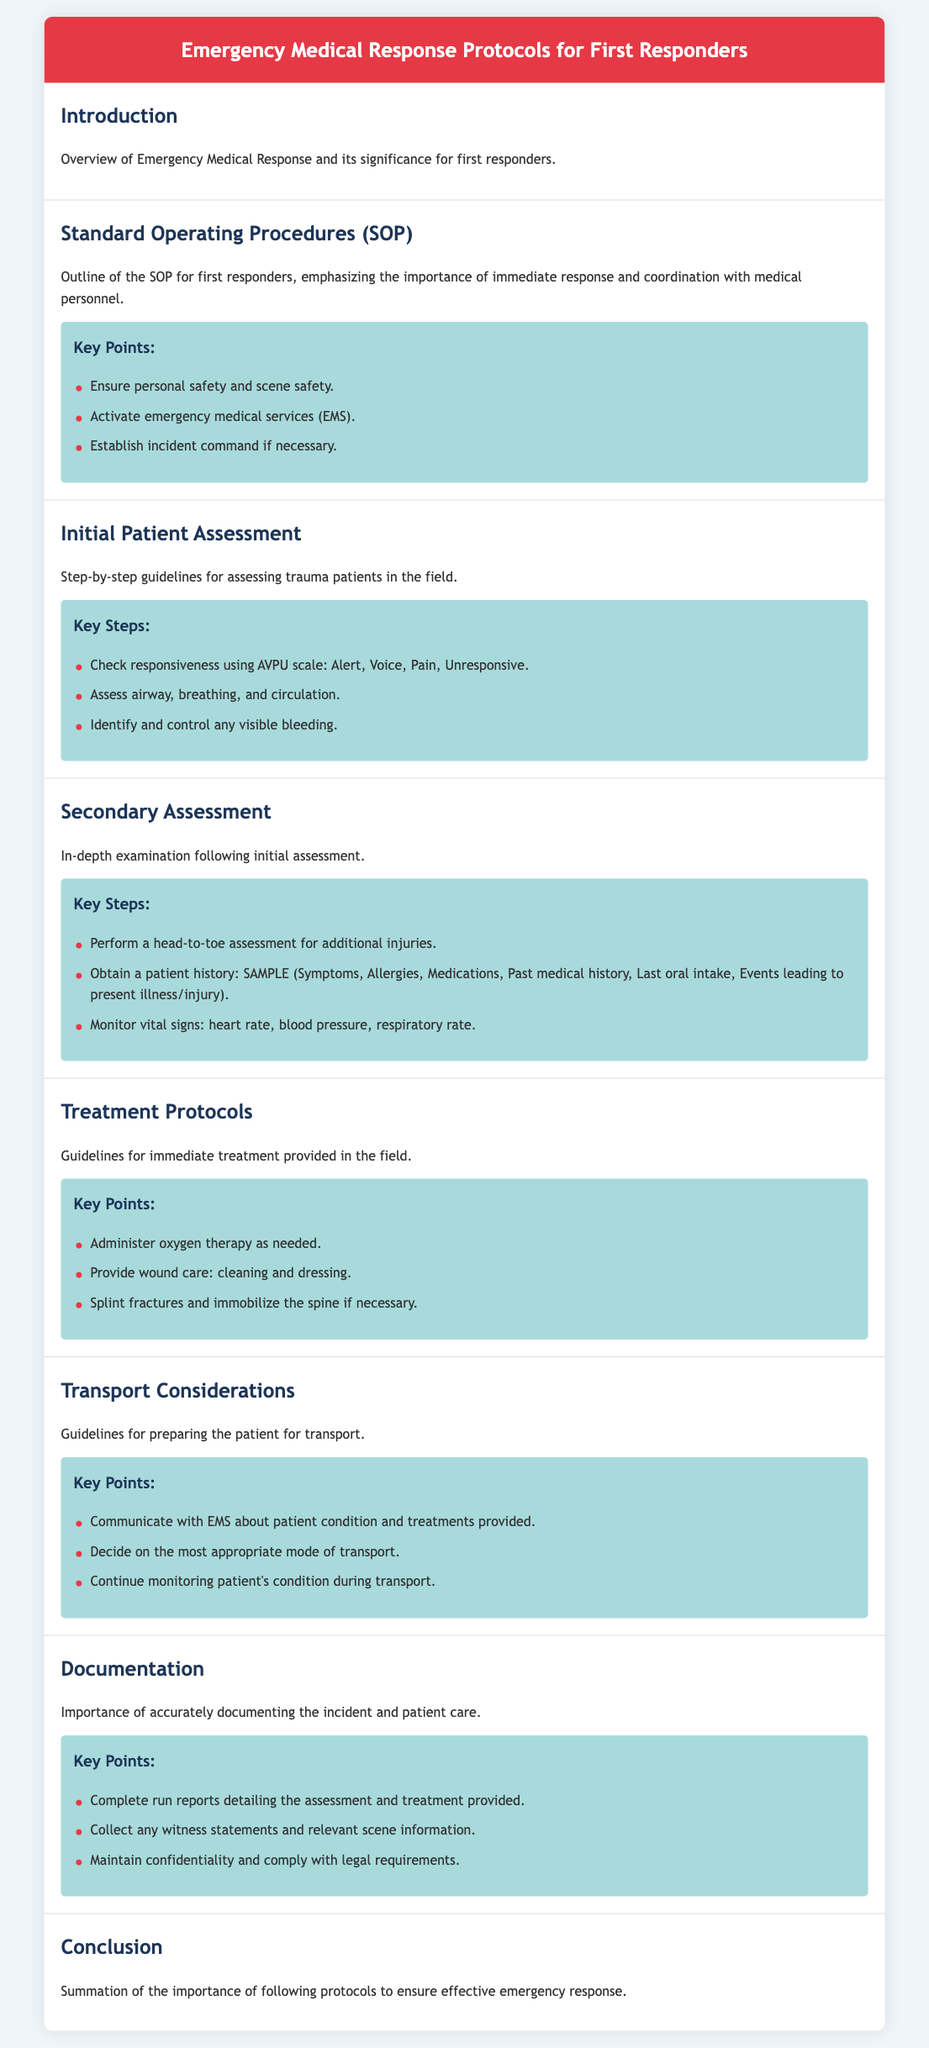what is the title of the document? The title mentioned at the top of the document outlines the subject matter it covers, which is specifically related to emergency medical protocols.
Answer: Emergency Medical Response Protocols for First Responders what is the first key point listed under Standard Operating Procedures? The first key point emphasizes the critical need for safety in emergency situations, which is vital for first responders.
Answer: Ensure personal safety and scene safety how many key steps are listed under Initial Patient Assessment? The document states key steps that guide responders in performing an initial assessment, which helps in triaging patients effectively.
Answer: Three what does the acronym SAMPLE stand for? The acronym represents elements to be obtained in patient history, providing a structured way to remember important information.
Answer: Symptoms, Allergies, Medications, Past medical history, Last oral intake, Events leading to present illness/injury which treatment is suggested for wounds? The document provides specific protocols for handling wounds effectively to minimize complications and promote healing.
Answer: Cleaning and dressing what is the indication for administering oxygen therapy? This protocol highlights the importance of oxygen therapy in supporting trauma patients, particularly in unstable conditions.
Answer: As needed how many key points are outlined for Transport Considerations? The transport guidelines include essential points that a first responder must follow to ensure the patient's continued safety and proper care during transport.
Answer: Three what is the final section of the document titled? This title signifies a summary that reiterates the importance of following established procedures in emergency medical situations.
Answer: Conclusion what is emphasized in the Documentation section? The importance highlighted here refers to the legal and medical necessity of accurate and thorough documentation after patient care.
Answer: Importance of accurately documenting the incident and patient care 